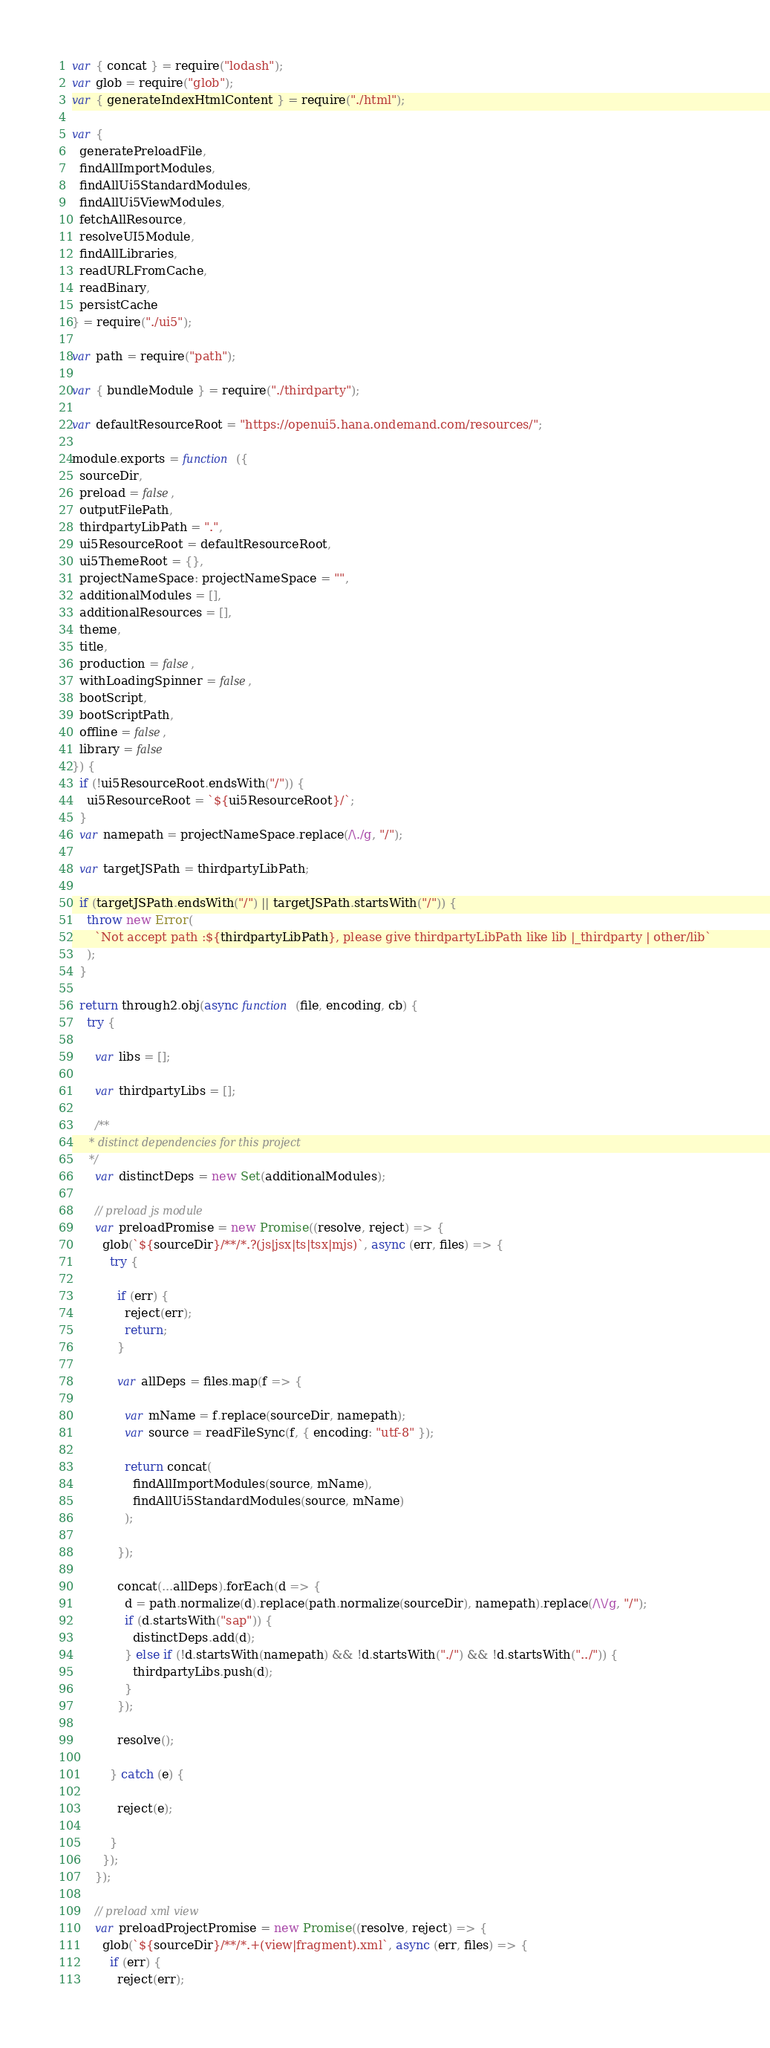<code> <loc_0><loc_0><loc_500><loc_500><_JavaScript_>var { concat } = require("lodash");
var glob = require("glob");
var { generateIndexHtmlContent } = require("./html");

var {
  generatePreloadFile,
  findAllImportModules,
  findAllUi5StandardModules,
  findAllUi5ViewModules,
  fetchAllResource,
  resolveUI5Module,
  findAllLibraries,
  readURLFromCache,
  readBinary,
  persistCache
} = require("./ui5");

var path = require("path");

var { bundleModule } = require("./thirdparty");

var defaultResourceRoot = "https://openui5.hana.ondemand.com/resources/";

module.exports = function ({
  sourceDir,
  preload = false,
  outputFilePath,
  thirdpartyLibPath = ".",
  ui5ResourceRoot = defaultResourceRoot,
  ui5ThemeRoot = {},
  projectNameSpace: projectNameSpace = "",
  additionalModules = [],
  additionalResources = [],
  theme,
  title,
  production = false,
  withLoadingSpinner = false,
  bootScript,
  bootScriptPath,
  offline = false,
  library = false
}) {
  if (!ui5ResourceRoot.endsWith("/")) {
    ui5ResourceRoot = `${ui5ResourceRoot}/`;
  }
  var namepath = projectNameSpace.replace(/\./g, "/");

  var targetJSPath = thirdpartyLibPath;

  if (targetJSPath.endsWith("/") || targetJSPath.startsWith("/")) {
    throw new Error(
      `Not accept path :${thirdpartyLibPath}, please give thirdpartyLibPath like lib |_thirdparty | other/lib`
    );
  }

  return through2.obj(async function (file, encoding, cb) {
    try {

      var libs = [];

      var thirdpartyLibs = [];

      /**
     * distinct dependencies for this project
     */
      var distinctDeps = new Set(additionalModules);

      // preload js module
      var preloadPromise = new Promise((resolve, reject) => {
        glob(`${sourceDir}/**/*.?(js|jsx|ts|tsx|mjs)`, async (err, files) => {
          try {

            if (err) {
              reject(err);
              return;
            }

            var allDeps = files.map(f => {

              var mName = f.replace(sourceDir, namepath);
              var source = readFileSync(f, { encoding: "utf-8" });

              return concat(
                findAllImportModules(source, mName),
                findAllUi5StandardModules(source, mName)
              );

            });

            concat(...allDeps).forEach(d => {
              d = path.normalize(d).replace(path.normalize(sourceDir), namepath).replace(/\\/g, "/");
              if (d.startsWith("sap")) {
                distinctDeps.add(d);
              } else if (!d.startsWith(namepath) && !d.startsWith("./") && !d.startsWith("../")) {
                thirdpartyLibs.push(d);
              }
            });

            resolve();

          } catch (e) {

            reject(e);

          }
        });
      });

      // preload xml view
      var preloadProjectPromise = new Promise((resolve, reject) => {
        glob(`${sourceDir}/**/*.+(view|fragment).xml`, async (err, files) => {
          if (err) {
            reject(err);</code> 